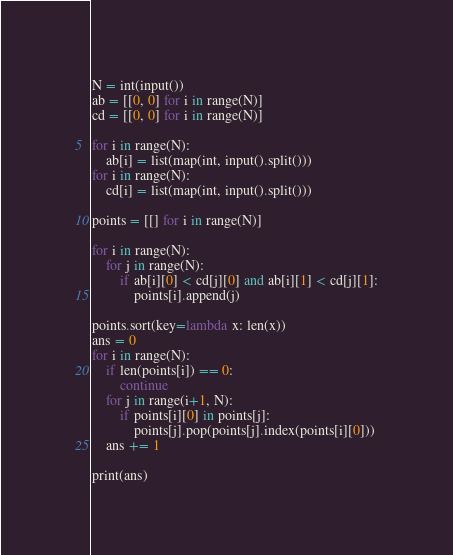<code> <loc_0><loc_0><loc_500><loc_500><_Python_>N = int(input())
ab = [[0, 0] for i in range(N)]
cd = [[0, 0] for i in range(N)]

for i in range(N):
    ab[i] = list(map(int, input().split()))
for i in range(N):
    cd[i] = list(map(int, input().split()))

points = [[] for i in range(N)]

for i in range(N):
    for j in range(N):
        if ab[i][0] < cd[j][0] and ab[i][1] < cd[j][1]:
            points[i].append(j)

points.sort(key=lambda x: len(x))
ans = 0
for i in range(N):
    if len(points[i]) == 0:
        continue
    for j in range(i+1, N):
        if points[i][0] in points[j]:
            points[j].pop(points[j].index(points[i][0]))
    ans += 1

print(ans)
</code> 